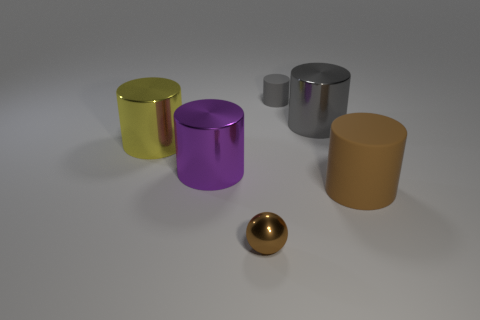What is the cylinder that is on the left side of the purple metal thing made of?
Give a very brief answer. Metal. What number of big things are purple cylinders or brown metal cylinders?
Your answer should be very brief. 1. There is a rubber object that is to the left of the brown matte cylinder; is it the same size as the big brown object?
Give a very brief answer. No. What is the brown ball made of?
Keep it short and to the point. Metal. What is the material of the large object that is both in front of the yellow cylinder and to the left of the gray metal thing?
Provide a succinct answer. Metal. How many objects are big shiny things on the left side of the small metallic sphere or gray rubber cylinders?
Make the answer very short. 3. Is the big matte cylinder the same color as the tiny metal sphere?
Your answer should be compact. Yes. Are there any red rubber things of the same size as the brown matte cylinder?
Your answer should be compact. No. What number of objects are both in front of the purple cylinder and behind the yellow shiny thing?
Offer a terse response. 0. There is a purple shiny cylinder; what number of tiny metallic objects are to the right of it?
Offer a terse response. 1. 